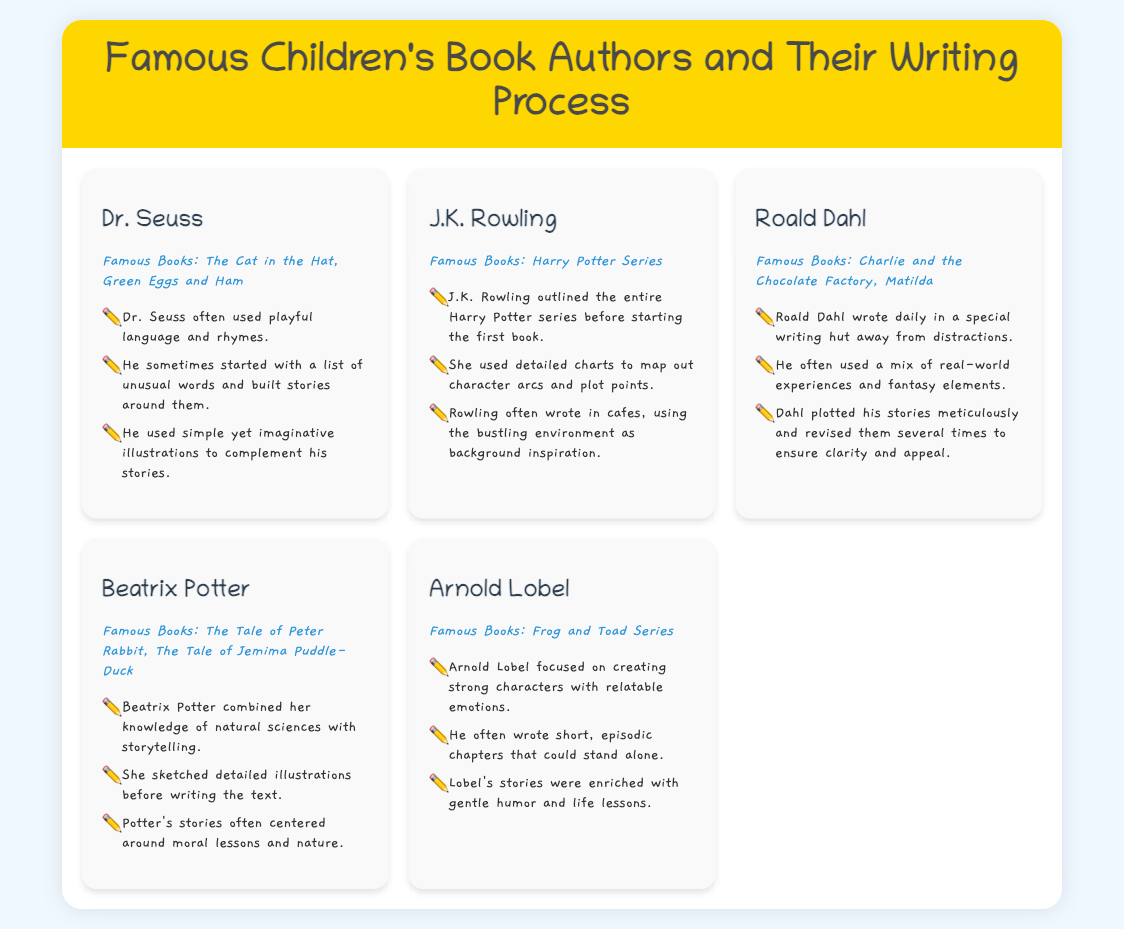What are the famous books by Dr. Seuss? The document lists "The Cat in the Hat" and "Green Eggs and Ham" as famous books by Dr. Seuss.
Answer: The Cat in the Hat, Green Eggs and Ham How did J.K. Rowling outline her writing? The document states that J.K. Rowling outlined the entire Harry Potter series before starting the first book.
Answer: Outlined the entire series Where did J.K. Rowling often write? The document mentions that she often wrote in cafes.
Answer: Cafes What did Roald Dahl use for his writing? According to the document, Roald Dahl wrote in a special writing hut away from distractions.
Answer: Writing hut What is a key aspect of Beatrix Potter's writing style? The document states that she combined her knowledge of natural sciences with storytelling.
Answer: Knowledge of natural sciences What theme is common in Beatrix Potter's stories? The document notes that her stories often centered around moral lessons and nature.
Answer: Moral lessons and nature How did Arnold Lobel structure his stories? The document indicates that he often wrote short, episodic chapters that could stand alone.
Answer: Short, episodic chapters Which author used playful language and rhymes? The document mentions that Dr. Seuss often used playful language and rhymes.
Answer: Dr. Seuss What kind of illustrations did Dr. Seuss use? The document highlights that he used simple yet imaginative illustrations.
Answer: Simple yet imaginative illustrations 